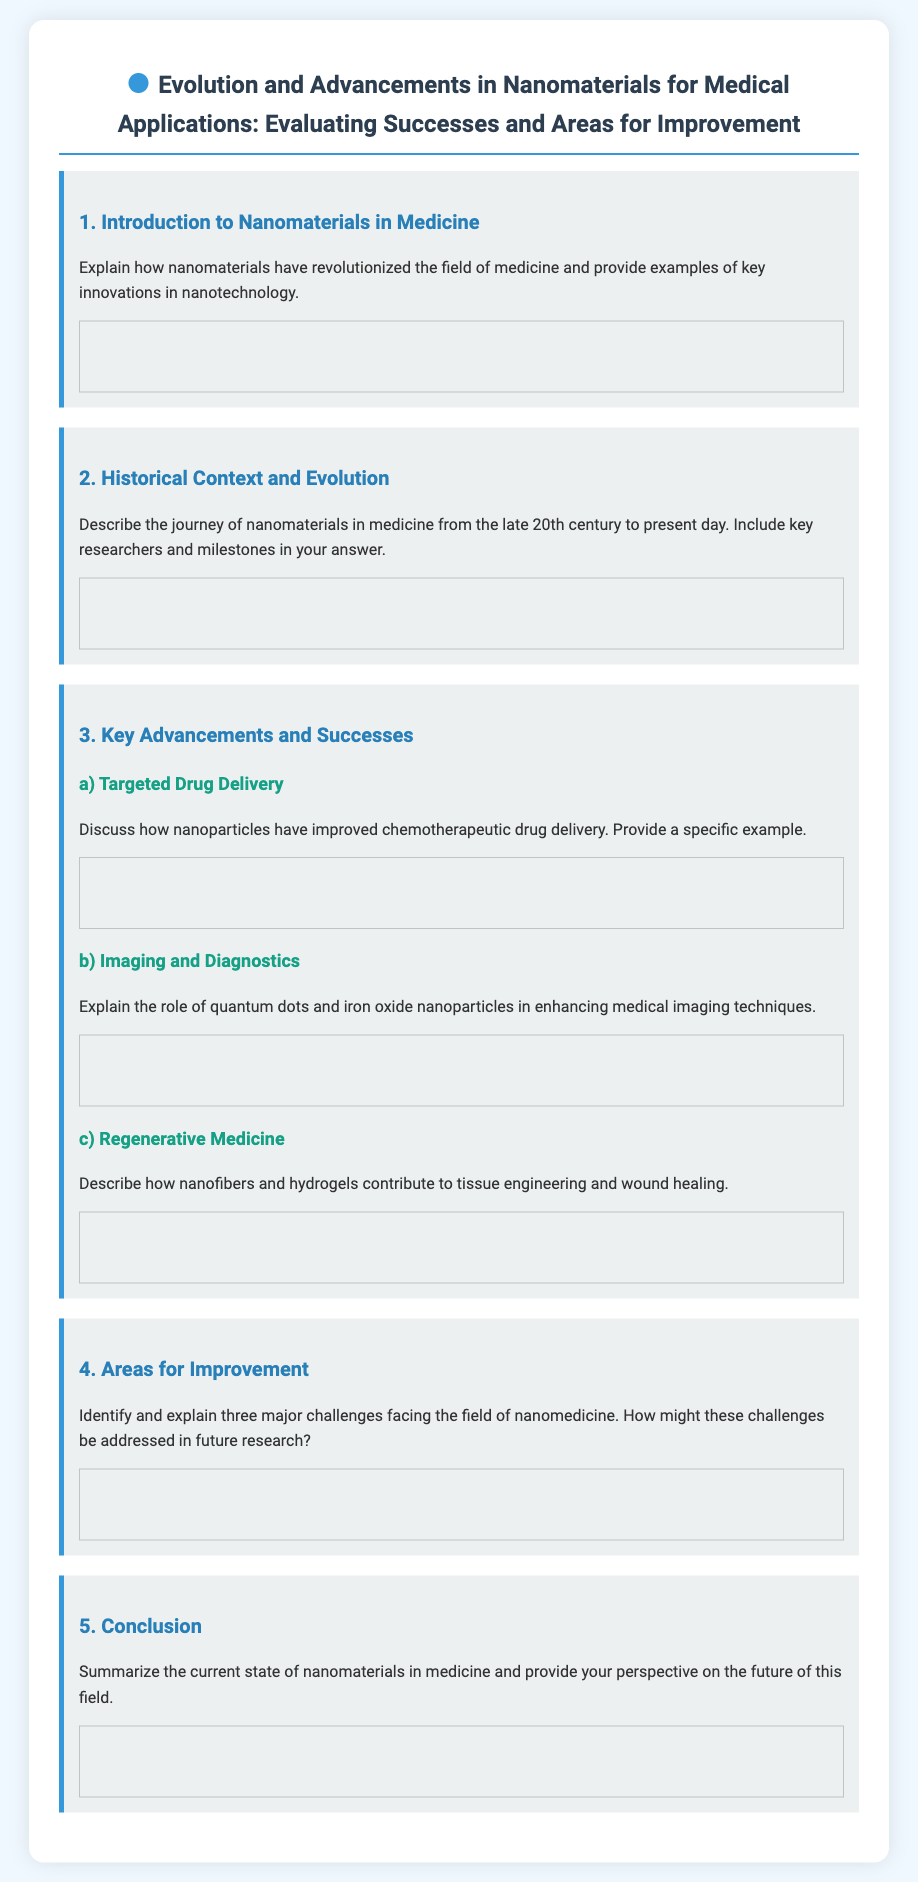What is the title of the exam? The title appears in the header section of the document and is: "Evolution and Advancements in Nanomaterials for Medical Applications: Evaluating Successes and Areas for Improvement."
Answer: Evolution and Advancements in Nanomaterials for Medical Applications: Evaluating Successes and Areas for Improvement How many main sections are there in the exam? The document contains a total of five main sections outlined with headings: 1) Introduction to Nanomaterials in Medicine, 2) Historical Context and Evolution, 3) Key Advancements and Successes, 4) Areas for Improvement, and 5) Conclusion.
Answer: Five What does section 3 focus on? Section 3 contains a breakdown of advancements, detailing subtopics such as targeted drug delivery, imaging and diagnostics, and regenerative medicine.
Answer: Key Advancements and Successes In which section can you find discussions about challenges facing nanomedicine? The challenges are discussed in section 4, titled "Areas for Improvement."
Answer: Areas for Improvement What type of nanoparticles are mentioned in enhancing medical imaging techniques? The document specifically mentions "quantum dots and iron oxide nanoparticles" as roles in improving imaging.
Answer: Quantum dots and iron oxide nanoparticles What is discussed under subsection 3a)? Subsection 3a) covers how "nanoparticles have improved chemotherapeutic drug delivery" and asks for a specific example.
Answer: Targeted Drug Delivery Which elements of nanomaterials contribute to tissue engineering? The document refers to "nanofibers and hydrogels" as contributions to tissue engineering and wound healing.
Answer: Nanofibers and hydrogels What does the conclusion section ask for? The conclusion section instructs to "summarize the current state of nanomaterials in medicine" and provides a perspective on the future of this field.
Answer: Summarize the current state of nanomaterials in medicine 